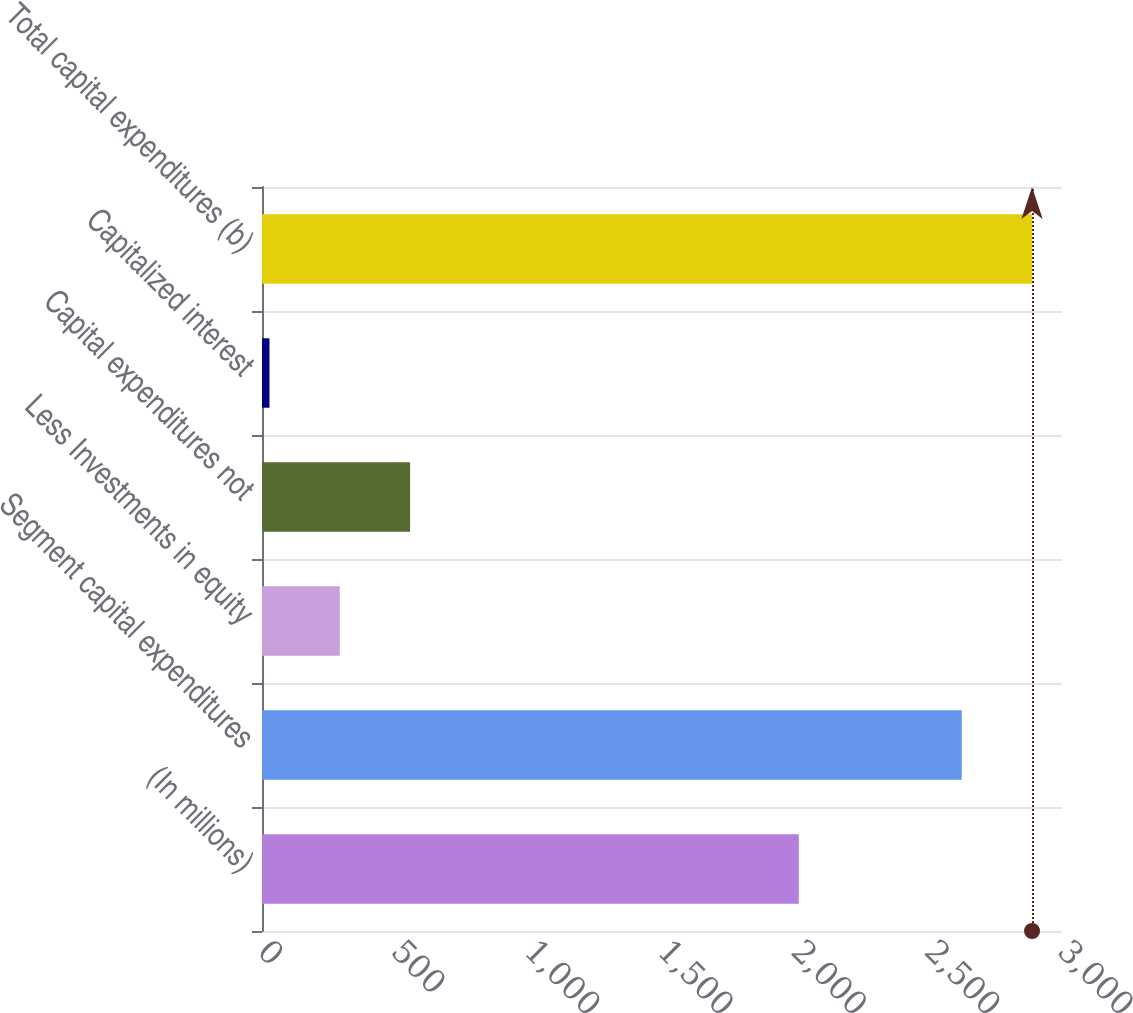<chart> <loc_0><loc_0><loc_500><loc_500><bar_chart><fcel>(In millions)<fcel>Segment capital expenditures<fcel>Less Investments in equity<fcel>Capital expenditures not<fcel>Capitalized interest<fcel>Total capital expenditures (b)<nl><fcel>2013<fcel>2624<fcel>291.7<fcel>555.4<fcel>28<fcel>2887.7<nl></chart> 